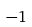<formula> <loc_0><loc_0><loc_500><loc_500>- 1</formula> 